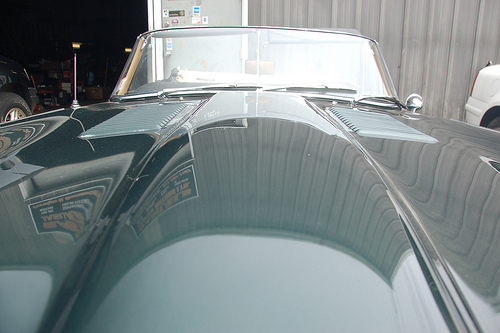<image>
Can you confirm if the doorknob is behind the windshield? Yes. From this viewpoint, the doorknob is positioned behind the windshield, with the windshield partially or fully occluding the doorknob. 